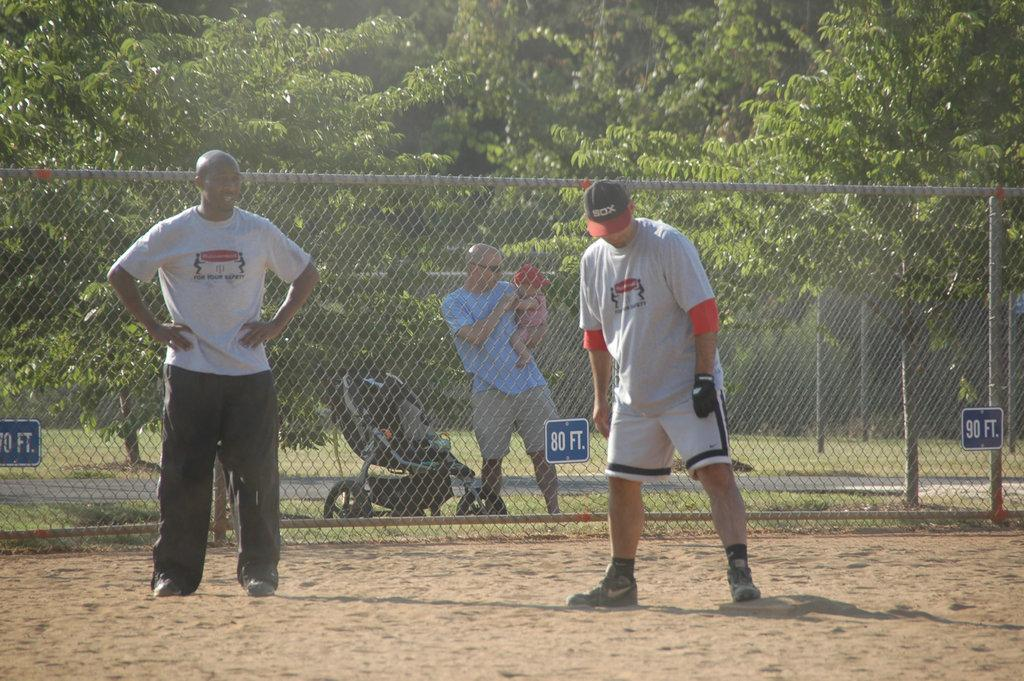<image>
Render a clear and concise summary of the photo. Two men wearing athletic clothes are standing in a dirt field in front of the fence where it says 80 ft. 